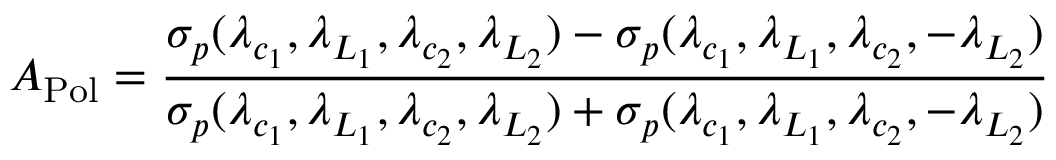Convert formula to latex. <formula><loc_0><loc_0><loc_500><loc_500>A _ { P o l } = \frac { \sigma _ { p } ( \lambda _ { c _ { 1 } } , \lambda _ { L _ { 1 } } , \lambda _ { c _ { 2 } } , \lambda _ { L _ { 2 } } ) - \sigma _ { p } ( \lambda _ { c _ { 1 } } , \lambda _ { L _ { 1 } } , \lambda _ { c _ { 2 } } , - \lambda _ { L _ { 2 } } ) } { \sigma _ { p } ( \lambda _ { c _ { 1 } } , \lambda _ { L _ { 1 } } , \lambda _ { c _ { 2 } } , \lambda _ { L _ { 2 } } ) + \sigma _ { p } ( \lambda _ { c _ { 1 } } , \lambda _ { L _ { 1 } } , \lambda _ { c _ { 2 } } , - \lambda _ { L _ { 2 } } ) }</formula> 